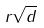Convert formula to latex. <formula><loc_0><loc_0><loc_500><loc_500>r \sqrt { d }</formula> 